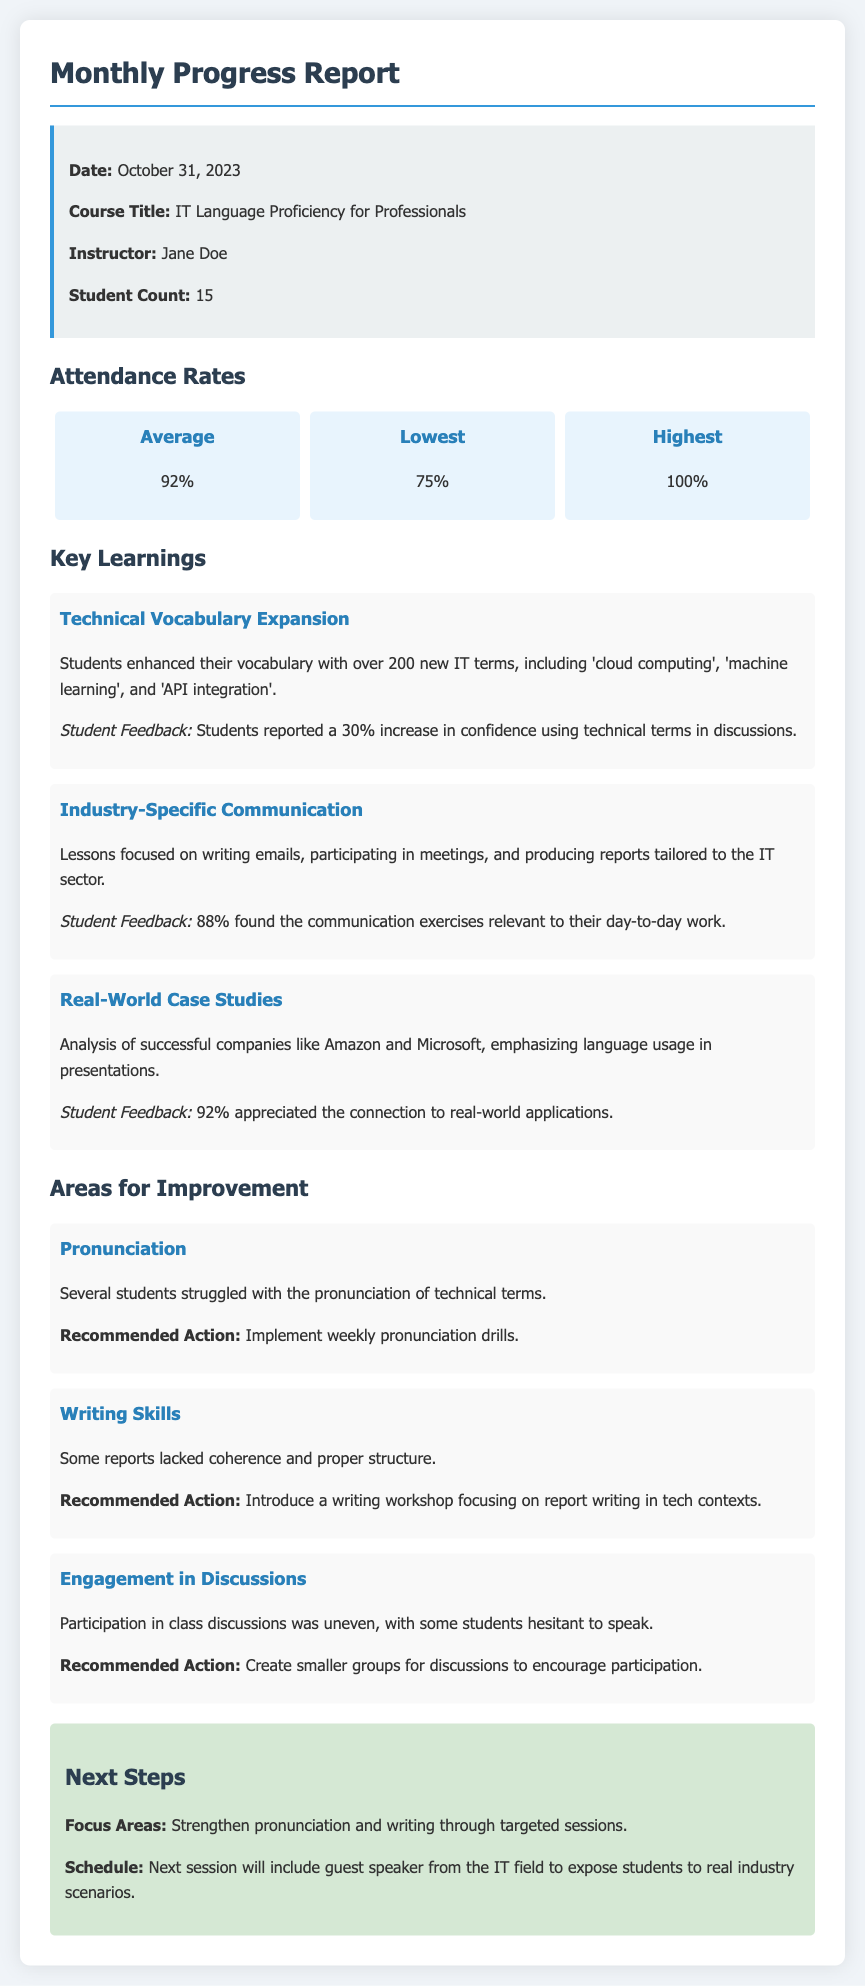What is the date of the report? The date of the report is stated at the beginning of the document, which is October 31, 2023.
Answer: October 31, 2023 Who is the instructor? The instructor's name is mentioned in the info box section of the document.
Answer: Jane Doe How many students are enrolled in the course? The document specifies the student count, which is found in the info box.
Answer: 15 What is the average attendance rate? The average attendance rate is listed in the attendance rates section of the report.
Answer: 92% What was the lowest attendance rate? The lowest attendance rate is provided in the attendance rates section of the document.
Answer: 75% Which skill area is identified for improvement regarding technical terms? The document lists several areas for improvement, specifically relating to pronunciation issues.
Answer: Pronunciation What percentage found the communication exercises relevant? The percentage is given in the key learnings section, highlighting student feedback on communication exercises.
Answer: 88% What is one suggested action for improving writing skills? The report offers recommendations for each area for improvement, including a specific action for writing skills.
Answer: Introduce a writing workshop What kind of guest will be present in the next session? The next steps section outlines what is expected in the upcoming class, including the type of guest speaker.
Answer: Guest speaker from the IT field 